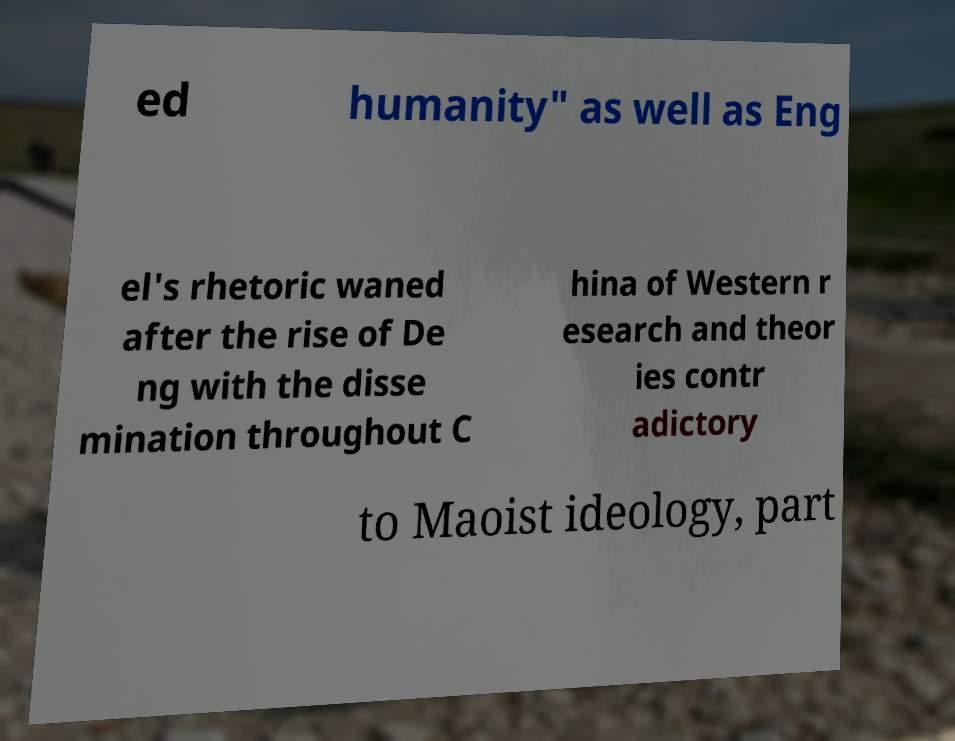Can you accurately transcribe the text from the provided image for me? ed humanity" as well as Eng el's rhetoric waned after the rise of De ng with the disse mination throughout C hina of Western r esearch and theor ies contr adictory to Maoist ideology, part 